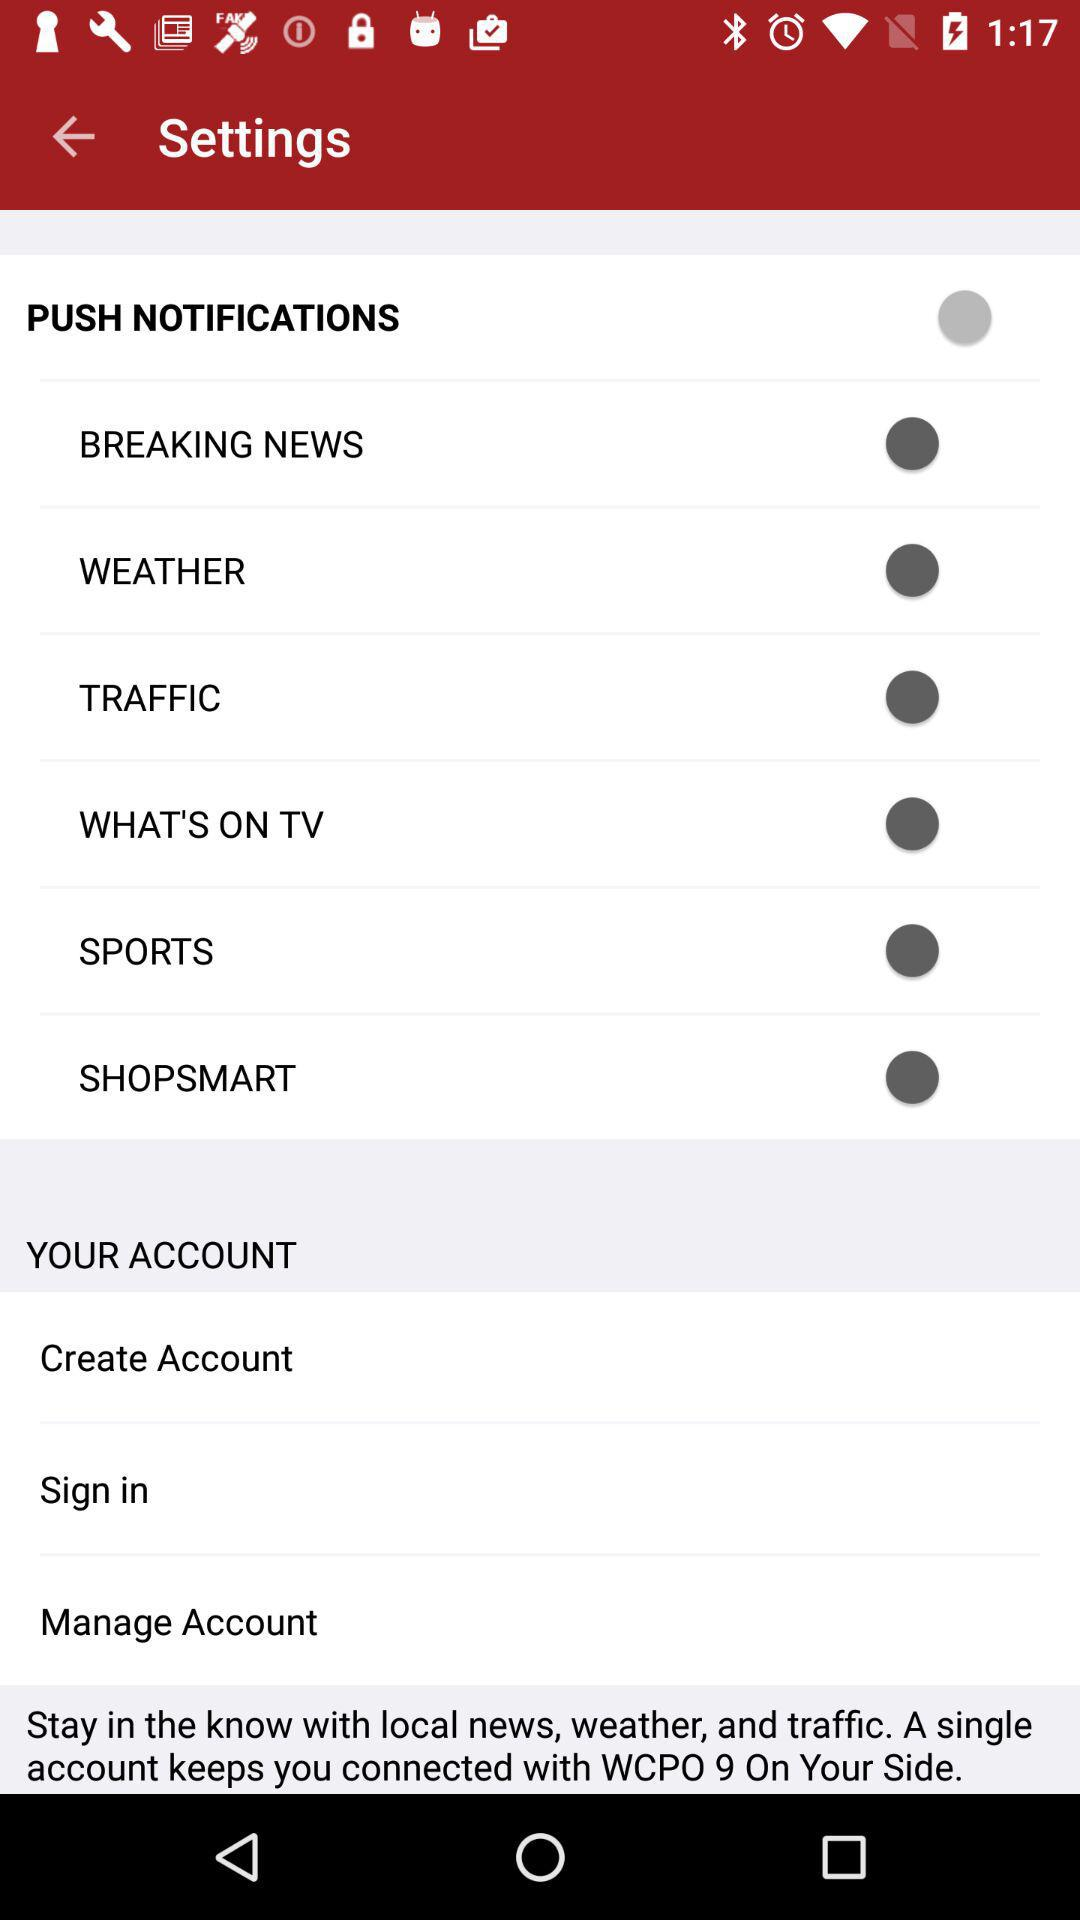What is the status of "Breaking News"? The status is "off". 